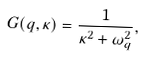<formula> <loc_0><loc_0><loc_500><loc_500>G ( q , \kappa ) = \frac { 1 } { \kappa ^ { 2 } + \omega _ { q } ^ { 2 } } ,</formula> 